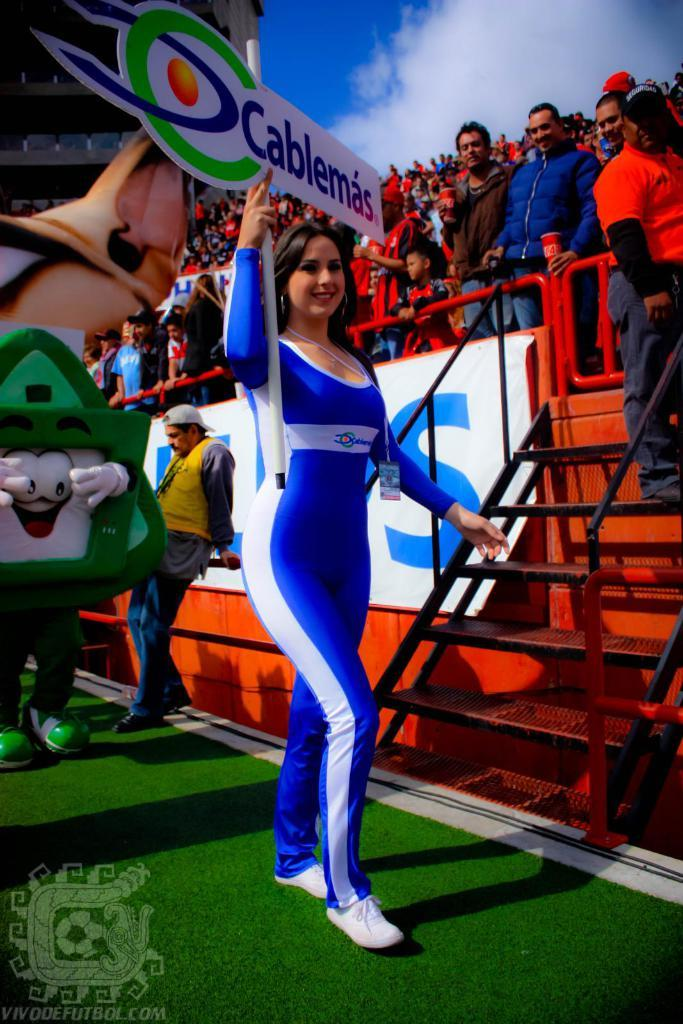<image>
Summarize the visual content of the image. A women in a white and blue jumpsuit holding a Cablemas sign. 